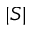<formula> <loc_0><loc_0><loc_500><loc_500>| { S } |</formula> 